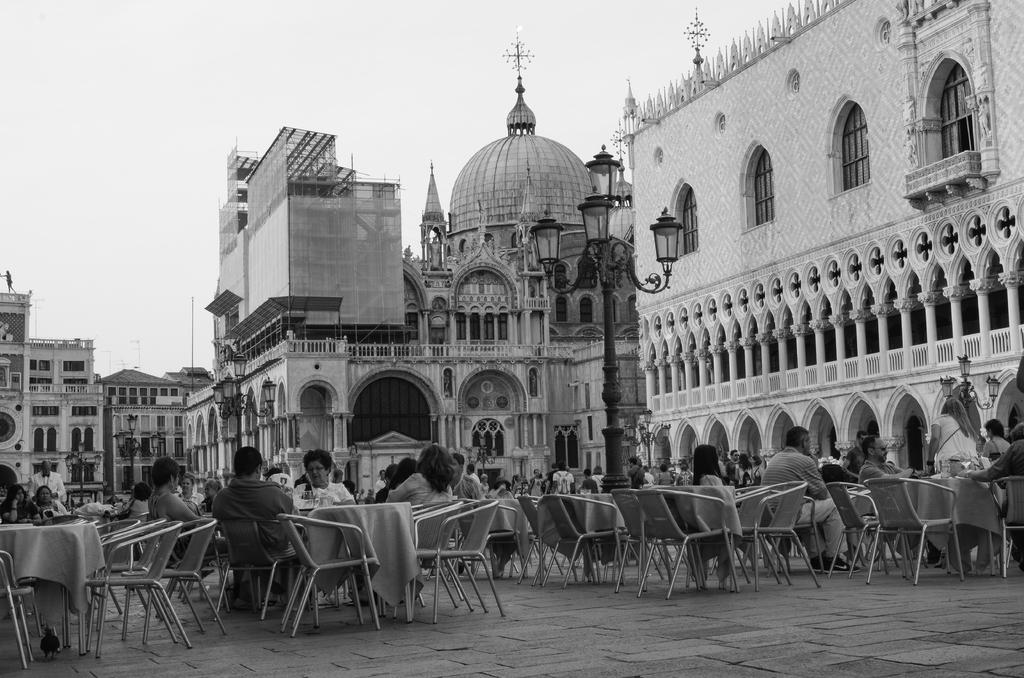What are the people in the image doing? The people in the image are sitting on chairs or standing or sitting around. What is present in the image that might be used for placing objects? There is a table in the image that can be used for placing objects. What can be seen in the background of the image? There is a building visible in the background of the image. What invention is being demonstrated by the people in the image? There is no invention being demonstrated in the image; the people are simply sitting or standing around. How many hands are visible in the image? The number of hands visible in the image cannot be determined from the provided facts, as it depends on the number of people and their positions. 